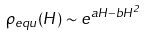Convert formula to latex. <formula><loc_0><loc_0><loc_500><loc_500>\rho _ { e q u } ( H ) \sim e ^ { a H - b H ^ { 2 } }</formula> 